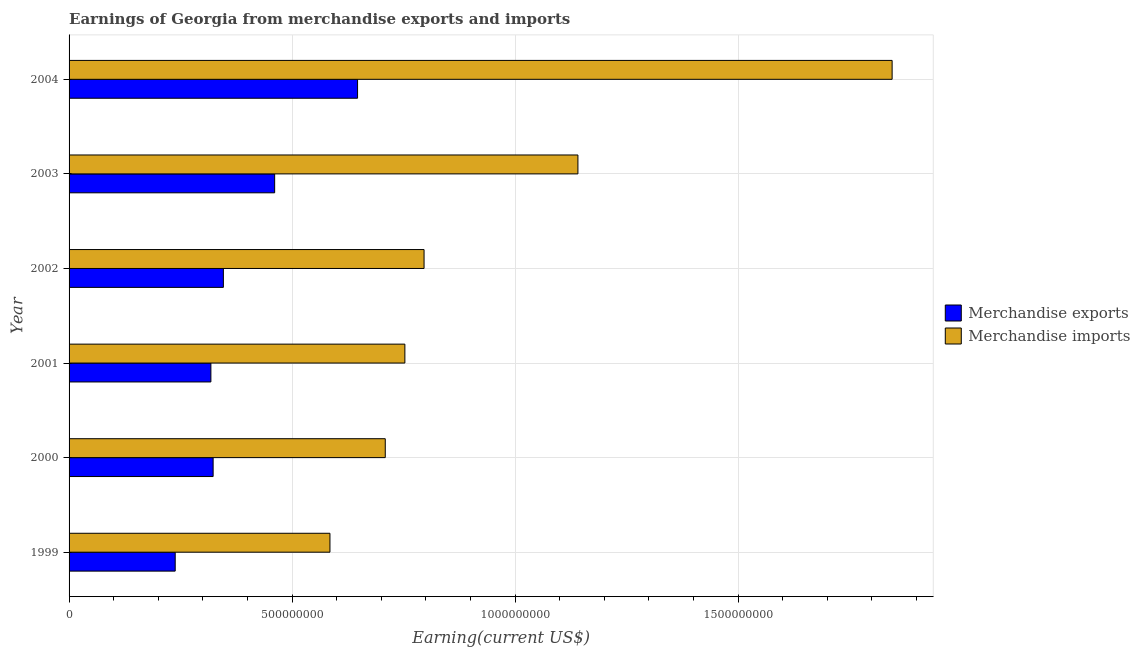How many groups of bars are there?
Ensure brevity in your answer.  6. How many bars are there on the 1st tick from the bottom?
Give a very brief answer. 2. In how many cases, is the number of bars for a given year not equal to the number of legend labels?
Your answer should be compact. 0. What is the earnings from merchandise imports in 2003?
Offer a very short reply. 1.14e+09. Across all years, what is the maximum earnings from merchandise imports?
Your answer should be very brief. 1.85e+09. Across all years, what is the minimum earnings from merchandise imports?
Your response must be concise. 5.85e+08. In which year was the earnings from merchandise exports maximum?
Provide a succinct answer. 2004. What is the total earnings from merchandise imports in the graph?
Ensure brevity in your answer.  5.83e+09. What is the difference between the earnings from merchandise exports in 2002 and that in 2003?
Ensure brevity in your answer.  -1.15e+08. What is the difference between the earnings from merchandise imports in 2004 and the earnings from merchandise exports in 2003?
Your answer should be compact. 1.38e+09. What is the average earnings from merchandise imports per year?
Your answer should be very brief. 9.72e+08. In the year 2001, what is the difference between the earnings from merchandise imports and earnings from merchandise exports?
Your answer should be compact. 4.35e+08. In how many years, is the earnings from merchandise exports greater than 1800000000 US$?
Offer a terse response. 0. What is the ratio of the earnings from merchandise imports in 2002 to that in 2004?
Your answer should be very brief. 0.43. Is the earnings from merchandise imports in 2000 less than that in 2004?
Provide a short and direct response. Yes. What is the difference between the highest and the second highest earnings from merchandise exports?
Give a very brief answer. 1.86e+08. What is the difference between the highest and the lowest earnings from merchandise imports?
Your response must be concise. 1.26e+09. In how many years, is the earnings from merchandise imports greater than the average earnings from merchandise imports taken over all years?
Make the answer very short. 2. Is the sum of the earnings from merchandise imports in 2001 and 2004 greater than the maximum earnings from merchandise exports across all years?
Provide a succinct answer. Yes. What does the 2nd bar from the top in 2001 represents?
Provide a succinct answer. Merchandise exports. What does the 2nd bar from the bottom in 2003 represents?
Give a very brief answer. Merchandise imports. How many years are there in the graph?
Offer a very short reply. 6. Does the graph contain any zero values?
Your answer should be compact. No. Where does the legend appear in the graph?
Keep it short and to the point. Center right. How many legend labels are there?
Provide a succinct answer. 2. What is the title of the graph?
Your response must be concise. Earnings of Georgia from merchandise exports and imports. Does "Primary completion rate" appear as one of the legend labels in the graph?
Ensure brevity in your answer.  No. What is the label or title of the X-axis?
Your answer should be very brief. Earning(current US$). What is the label or title of the Y-axis?
Your response must be concise. Year. What is the Earning(current US$) of Merchandise exports in 1999?
Your answer should be very brief. 2.38e+08. What is the Earning(current US$) of Merchandise imports in 1999?
Offer a terse response. 5.85e+08. What is the Earning(current US$) of Merchandise exports in 2000?
Your answer should be compact. 3.23e+08. What is the Earning(current US$) in Merchandise imports in 2000?
Your response must be concise. 7.09e+08. What is the Earning(current US$) in Merchandise exports in 2001?
Offer a very short reply. 3.18e+08. What is the Earning(current US$) in Merchandise imports in 2001?
Ensure brevity in your answer.  7.53e+08. What is the Earning(current US$) in Merchandise exports in 2002?
Give a very brief answer. 3.46e+08. What is the Earning(current US$) of Merchandise imports in 2002?
Ensure brevity in your answer.  7.96e+08. What is the Earning(current US$) in Merchandise exports in 2003?
Your answer should be very brief. 4.61e+08. What is the Earning(current US$) of Merchandise imports in 2003?
Your answer should be compact. 1.14e+09. What is the Earning(current US$) of Merchandise exports in 2004?
Make the answer very short. 6.47e+08. What is the Earning(current US$) of Merchandise imports in 2004?
Provide a succinct answer. 1.85e+09. Across all years, what is the maximum Earning(current US$) in Merchandise exports?
Provide a succinct answer. 6.47e+08. Across all years, what is the maximum Earning(current US$) of Merchandise imports?
Your answer should be compact. 1.85e+09. Across all years, what is the minimum Earning(current US$) in Merchandise exports?
Make the answer very short. 2.38e+08. Across all years, what is the minimum Earning(current US$) of Merchandise imports?
Your answer should be very brief. 5.85e+08. What is the total Earning(current US$) in Merchandise exports in the graph?
Offer a terse response. 2.33e+09. What is the total Earning(current US$) in Merchandise imports in the graph?
Your answer should be compact. 5.83e+09. What is the difference between the Earning(current US$) in Merchandise exports in 1999 and that in 2000?
Make the answer very short. -8.50e+07. What is the difference between the Earning(current US$) in Merchandise imports in 1999 and that in 2000?
Your answer should be very brief. -1.24e+08. What is the difference between the Earning(current US$) of Merchandise exports in 1999 and that in 2001?
Offer a very short reply. -8.00e+07. What is the difference between the Earning(current US$) of Merchandise imports in 1999 and that in 2001?
Your answer should be very brief. -1.68e+08. What is the difference between the Earning(current US$) of Merchandise exports in 1999 and that in 2002?
Keep it short and to the point. -1.08e+08. What is the difference between the Earning(current US$) in Merchandise imports in 1999 and that in 2002?
Your answer should be compact. -2.11e+08. What is the difference between the Earning(current US$) of Merchandise exports in 1999 and that in 2003?
Give a very brief answer. -2.23e+08. What is the difference between the Earning(current US$) in Merchandise imports in 1999 and that in 2003?
Your answer should be compact. -5.56e+08. What is the difference between the Earning(current US$) of Merchandise exports in 1999 and that in 2004?
Give a very brief answer. -4.09e+08. What is the difference between the Earning(current US$) of Merchandise imports in 1999 and that in 2004?
Keep it short and to the point. -1.26e+09. What is the difference between the Earning(current US$) in Merchandise imports in 2000 and that in 2001?
Your answer should be compact. -4.40e+07. What is the difference between the Earning(current US$) of Merchandise exports in 2000 and that in 2002?
Keep it short and to the point. -2.30e+07. What is the difference between the Earning(current US$) in Merchandise imports in 2000 and that in 2002?
Give a very brief answer. -8.70e+07. What is the difference between the Earning(current US$) of Merchandise exports in 2000 and that in 2003?
Your answer should be compact. -1.38e+08. What is the difference between the Earning(current US$) of Merchandise imports in 2000 and that in 2003?
Your response must be concise. -4.32e+08. What is the difference between the Earning(current US$) of Merchandise exports in 2000 and that in 2004?
Give a very brief answer. -3.24e+08. What is the difference between the Earning(current US$) in Merchandise imports in 2000 and that in 2004?
Keep it short and to the point. -1.14e+09. What is the difference between the Earning(current US$) in Merchandise exports in 2001 and that in 2002?
Make the answer very short. -2.80e+07. What is the difference between the Earning(current US$) of Merchandise imports in 2001 and that in 2002?
Make the answer very short. -4.30e+07. What is the difference between the Earning(current US$) of Merchandise exports in 2001 and that in 2003?
Keep it short and to the point. -1.43e+08. What is the difference between the Earning(current US$) in Merchandise imports in 2001 and that in 2003?
Your answer should be compact. -3.88e+08. What is the difference between the Earning(current US$) of Merchandise exports in 2001 and that in 2004?
Offer a very short reply. -3.29e+08. What is the difference between the Earning(current US$) of Merchandise imports in 2001 and that in 2004?
Your answer should be very brief. -1.09e+09. What is the difference between the Earning(current US$) in Merchandise exports in 2002 and that in 2003?
Your response must be concise. -1.15e+08. What is the difference between the Earning(current US$) of Merchandise imports in 2002 and that in 2003?
Provide a succinct answer. -3.45e+08. What is the difference between the Earning(current US$) of Merchandise exports in 2002 and that in 2004?
Make the answer very short. -3.01e+08. What is the difference between the Earning(current US$) in Merchandise imports in 2002 and that in 2004?
Provide a short and direct response. -1.05e+09. What is the difference between the Earning(current US$) of Merchandise exports in 2003 and that in 2004?
Make the answer very short. -1.86e+08. What is the difference between the Earning(current US$) of Merchandise imports in 2003 and that in 2004?
Your answer should be very brief. -7.05e+08. What is the difference between the Earning(current US$) in Merchandise exports in 1999 and the Earning(current US$) in Merchandise imports in 2000?
Make the answer very short. -4.71e+08. What is the difference between the Earning(current US$) in Merchandise exports in 1999 and the Earning(current US$) in Merchandise imports in 2001?
Offer a very short reply. -5.15e+08. What is the difference between the Earning(current US$) of Merchandise exports in 1999 and the Earning(current US$) of Merchandise imports in 2002?
Your answer should be very brief. -5.58e+08. What is the difference between the Earning(current US$) in Merchandise exports in 1999 and the Earning(current US$) in Merchandise imports in 2003?
Offer a very short reply. -9.03e+08. What is the difference between the Earning(current US$) of Merchandise exports in 1999 and the Earning(current US$) of Merchandise imports in 2004?
Ensure brevity in your answer.  -1.61e+09. What is the difference between the Earning(current US$) of Merchandise exports in 2000 and the Earning(current US$) of Merchandise imports in 2001?
Offer a terse response. -4.30e+08. What is the difference between the Earning(current US$) of Merchandise exports in 2000 and the Earning(current US$) of Merchandise imports in 2002?
Give a very brief answer. -4.73e+08. What is the difference between the Earning(current US$) in Merchandise exports in 2000 and the Earning(current US$) in Merchandise imports in 2003?
Provide a succinct answer. -8.18e+08. What is the difference between the Earning(current US$) in Merchandise exports in 2000 and the Earning(current US$) in Merchandise imports in 2004?
Provide a succinct answer. -1.52e+09. What is the difference between the Earning(current US$) of Merchandise exports in 2001 and the Earning(current US$) of Merchandise imports in 2002?
Keep it short and to the point. -4.78e+08. What is the difference between the Earning(current US$) in Merchandise exports in 2001 and the Earning(current US$) in Merchandise imports in 2003?
Give a very brief answer. -8.23e+08. What is the difference between the Earning(current US$) in Merchandise exports in 2001 and the Earning(current US$) in Merchandise imports in 2004?
Your response must be concise. -1.53e+09. What is the difference between the Earning(current US$) of Merchandise exports in 2002 and the Earning(current US$) of Merchandise imports in 2003?
Make the answer very short. -7.95e+08. What is the difference between the Earning(current US$) of Merchandise exports in 2002 and the Earning(current US$) of Merchandise imports in 2004?
Keep it short and to the point. -1.50e+09. What is the difference between the Earning(current US$) in Merchandise exports in 2003 and the Earning(current US$) in Merchandise imports in 2004?
Provide a succinct answer. -1.38e+09. What is the average Earning(current US$) of Merchandise exports per year?
Your answer should be compact. 3.89e+08. What is the average Earning(current US$) in Merchandise imports per year?
Your answer should be very brief. 9.72e+08. In the year 1999, what is the difference between the Earning(current US$) in Merchandise exports and Earning(current US$) in Merchandise imports?
Make the answer very short. -3.47e+08. In the year 2000, what is the difference between the Earning(current US$) in Merchandise exports and Earning(current US$) in Merchandise imports?
Your answer should be compact. -3.86e+08. In the year 2001, what is the difference between the Earning(current US$) in Merchandise exports and Earning(current US$) in Merchandise imports?
Provide a succinct answer. -4.35e+08. In the year 2002, what is the difference between the Earning(current US$) of Merchandise exports and Earning(current US$) of Merchandise imports?
Provide a succinct answer. -4.50e+08. In the year 2003, what is the difference between the Earning(current US$) of Merchandise exports and Earning(current US$) of Merchandise imports?
Offer a very short reply. -6.80e+08. In the year 2004, what is the difference between the Earning(current US$) in Merchandise exports and Earning(current US$) in Merchandise imports?
Keep it short and to the point. -1.20e+09. What is the ratio of the Earning(current US$) in Merchandise exports in 1999 to that in 2000?
Provide a succinct answer. 0.74. What is the ratio of the Earning(current US$) in Merchandise imports in 1999 to that in 2000?
Offer a terse response. 0.83. What is the ratio of the Earning(current US$) of Merchandise exports in 1999 to that in 2001?
Provide a short and direct response. 0.75. What is the ratio of the Earning(current US$) in Merchandise imports in 1999 to that in 2001?
Your answer should be very brief. 0.78. What is the ratio of the Earning(current US$) in Merchandise exports in 1999 to that in 2002?
Give a very brief answer. 0.69. What is the ratio of the Earning(current US$) of Merchandise imports in 1999 to that in 2002?
Offer a very short reply. 0.73. What is the ratio of the Earning(current US$) of Merchandise exports in 1999 to that in 2003?
Your response must be concise. 0.52. What is the ratio of the Earning(current US$) in Merchandise imports in 1999 to that in 2003?
Offer a terse response. 0.51. What is the ratio of the Earning(current US$) of Merchandise exports in 1999 to that in 2004?
Your answer should be very brief. 0.37. What is the ratio of the Earning(current US$) in Merchandise imports in 1999 to that in 2004?
Provide a short and direct response. 0.32. What is the ratio of the Earning(current US$) of Merchandise exports in 2000 to that in 2001?
Offer a very short reply. 1.02. What is the ratio of the Earning(current US$) in Merchandise imports in 2000 to that in 2001?
Provide a succinct answer. 0.94. What is the ratio of the Earning(current US$) of Merchandise exports in 2000 to that in 2002?
Offer a very short reply. 0.93. What is the ratio of the Earning(current US$) of Merchandise imports in 2000 to that in 2002?
Offer a very short reply. 0.89. What is the ratio of the Earning(current US$) of Merchandise exports in 2000 to that in 2003?
Give a very brief answer. 0.7. What is the ratio of the Earning(current US$) of Merchandise imports in 2000 to that in 2003?
Provide a succinct answer. 0.62. What is the ratio of the Earning(current US$) of Merchandise exports in 2000 to that in 2004?
Your answer should be compact. 0.5. What is the ratio of the Earning(current US$) of Merchandise imports in 2000 to that in 2004?
Make the answer very short. 0.38. What is the ratio of the Earning(current US$) of Merchandise exports in 2001 to that in 2002?
Keep it short and to the point. 0.92. What is the ratio of the Earning(current US$) of Merchandise imports in 2001 to that in 2002?
Provide a short and direct response. 0.95. What is the ratio of the Earning(current US$) of Merchandise exports in 2001 to that in 2003?
Make the answer very short. 0.69. What is the ratio of the Earning(current US$) in Merchandise imports in 2001 to that in 2003?
Make the answer very short. 0.66. What is the ratio of the Earning(current US$) of Merchandise exports in 2001 to that in 2004?
Offer a terse response. 0.49. What is the ratio of the Earning(current US$) of Merchandise imports in 2001 to that in 2004?
Your response must be concise. 0.41. What is the ratio of the Earning(current US$) of Merchandise exports in 2002 to that in 2003?
Your answer should be compact. 0.75. What is the ratio of the Earning(current US$) of Merchandise imports in 2002 to that in 2003?
Make the answer very short. 0.7. What is the ratio of the Earning(current US$) in Merchandise exports in 2002 to that in 2004?
Ensure brevity in your answer.  0.53. What is the ratio of the Earning(current US$) in Merchandise imports in 2002 to that in 2004?
Your answer should be very brief. 0.43. What is the ratio of the Earning(current US$) in Merchandise exports in 2003 to that in 2004?
Give a very brief answer. 0.71. What is the ratio of the Earning(current US$) in Merchandise imports in 2003 to that in 2004?
Your answer should be compact. 0.62. What is the difference between the highest and the second highest Earning(current US$) in Merchandise exports?
Give a very brief answer. 1.86e+08. What is the difference between the highest and the second highest Earning(current US$) of Merchandise imports?
Your answer should be compact. 7.05e+08. What is the difference between the highest and the lowest Earning(current US$) of Merchandise exports?
Provide a short and direct response. 4.09e+08. What is the difference between the highest and the lowest Earning(current US$) in Merchandise imports?
Your answer should be compact. 1.26e+09. 